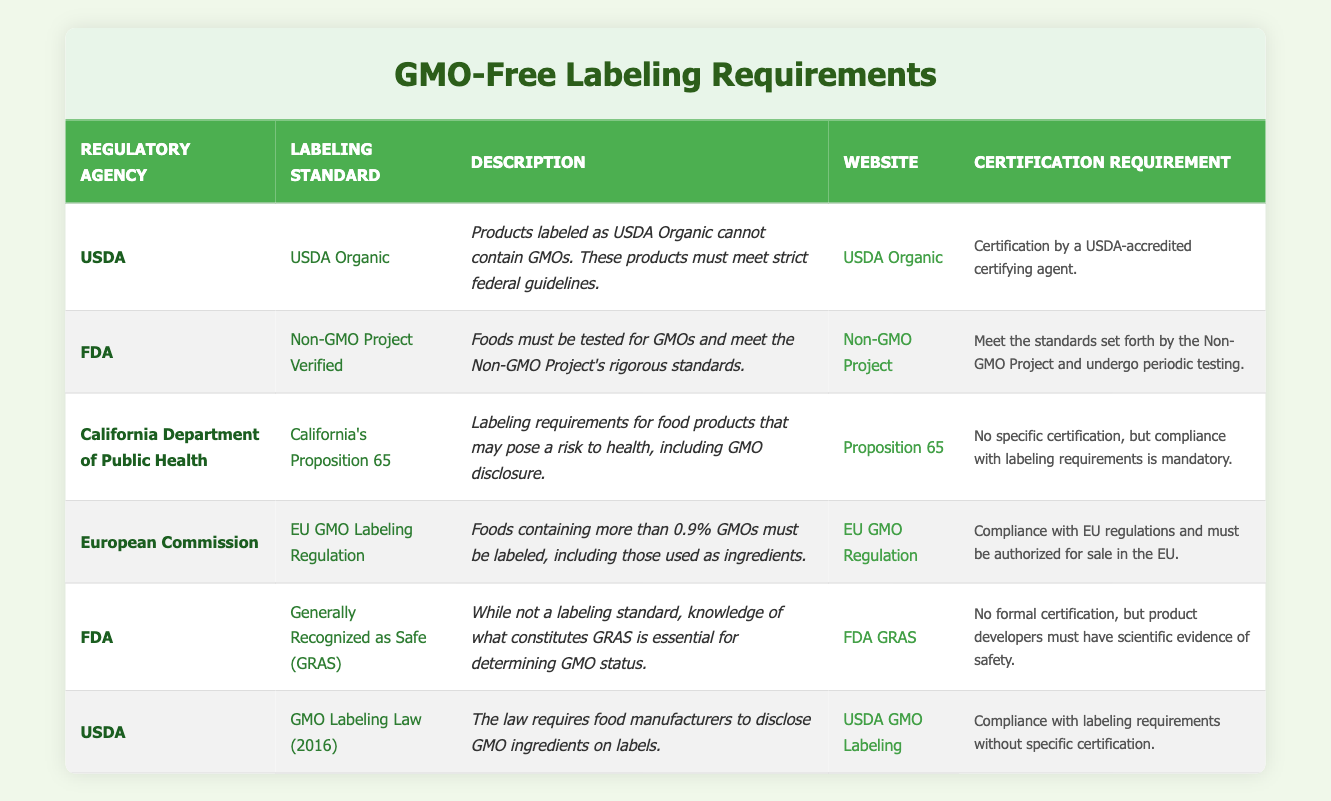What is the regulatory agency for the GMO Labeling Law? The table indicates that the regulatory agency for the GMO Labeling Law (2016) is USDA, which is listed under the relevant row.
Answer: USDA What labeling standard requires compliance with federal guidelines? Based on the table, the USDA Organic labeling standard specifically states that products must meet strict federal guidelines, as specified in its description.
Answer: USDA Organic How many labeling standards are provided by the FDA? Upon examining the table, there are two labeling standards provided by the FDA: Non-GMO Project Verified and Generally Recognized as Safe (GRAS). This is counted by identifying the FDA as the regulatory agency and listing the associated standards.
Answer: 2 Is certification by a USDA-accredited certifying agent required for GMO-free labeling? The table specifies that USDA Organic requires certification by a USDA-accredited certifying agent, while other labels like the GMO Labeling Law do not require specific certification. Thus, the answer is yes for USDA Organic, and the requirement varies for others.
Answer: Yes (for USDA Organic) Which labeling standard requires foods to be tested for GMOs? The table states that the Non-GMO Project Verified labeling standard requires foods to be tested for GMOs, as described in the corresponding row.
Answer: Non-GMO Project Verified What is the website for California's Proposition 65? According to the table, the website for California's Proposition 65 is listed as https://oehha.ca.gov/proposition-65, which is easily accessible in the corresponding row.
Answer: https://oehha.ca.gov/proposition-65 What percentage of GMOs triggers the EU labeling requirement? From the table, it is indicated that foods containing more than 0.9% GMOs must be labeled under the EU GMO Labeling Regulation, pointing to the numerical threshold specified in the description.
Answer: 0.9% What is the relationship between Generally Recognized as Safe (GRAS) and GMO status? The table indicates that GRAS is not a labeling standard itself but is essential for determining GMO status, indicating that developers need to gather scientific evidence of safety. The relationship emphasizes the importance of GRAS in assessing whether a product contains GMOs.
Answer: GRAS helps determine GMO status Are there any labeling standards listed that do not require a specific certification? Analyzing the table reveals that both California's Proposition 65 and the GMO Labeling Law (2016) do not require specific certifications according to their respective rows. Therefore, the answer is affirmative as multiple standards fall into this category.
Answer: Yes 